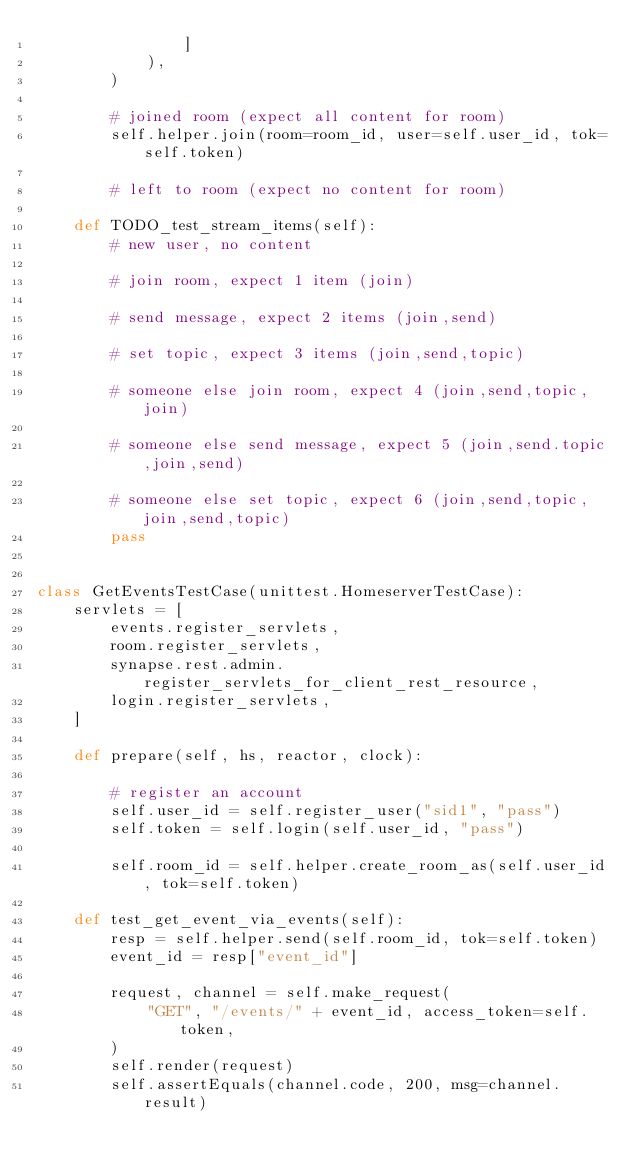Convert code to text. <code><loc_0><loc_0><loc_500><loc_500><_Python_>                ]
            ),
        )

        # joined room (expect all content for room)
        self.helper.join(room=room_id, user=self.user_id, tok=self.token)

        # left to room (expect no content for room)

    def TODO_test_stream_items(self):
        # new user, no content

        # join room, expect 1 item (join)

        # send message, expect 2 items (join,send)

        # set topic, expect 3 items (join,send,topic)

        # someone else join room, expect 4 (join,send,topic,join)

        # someone else send message, expect 5 (join,send.topic,join,send)

        # someone else set topic, expect 6 (join,send,topic,join,send,topic)
        pass


class GetEventsTestCase(unittest.HomeserverTestCase):
    servlets = [
        events.register_servlets,
        room.register_servlets,
        synapse.rest.admin.register_servlets_for_client_rest_resource,
        login.register_servlets,
    ]

    def prepare(self, hs, reactor, clock):

        # register an account
        self.user_id = self.register_user("sid1", "pass")
        self.token = self.login(self.user_id, "pass")

        self.room_id = self.helper.create_room_as(self.user_id, tok=self.token)

    def test_get_event_via_events(self):
        resp = self.helper.send(self.room_id, tok=self.token)
        event_id = resp["event_id"]

        request, channel = self.make_request(
            "GET", "/events/" + event_id, access_token=self.token,
        )
        self.render(request)
        self.assertEquals(channel.code, 200, msg=channel.result)
</code> 